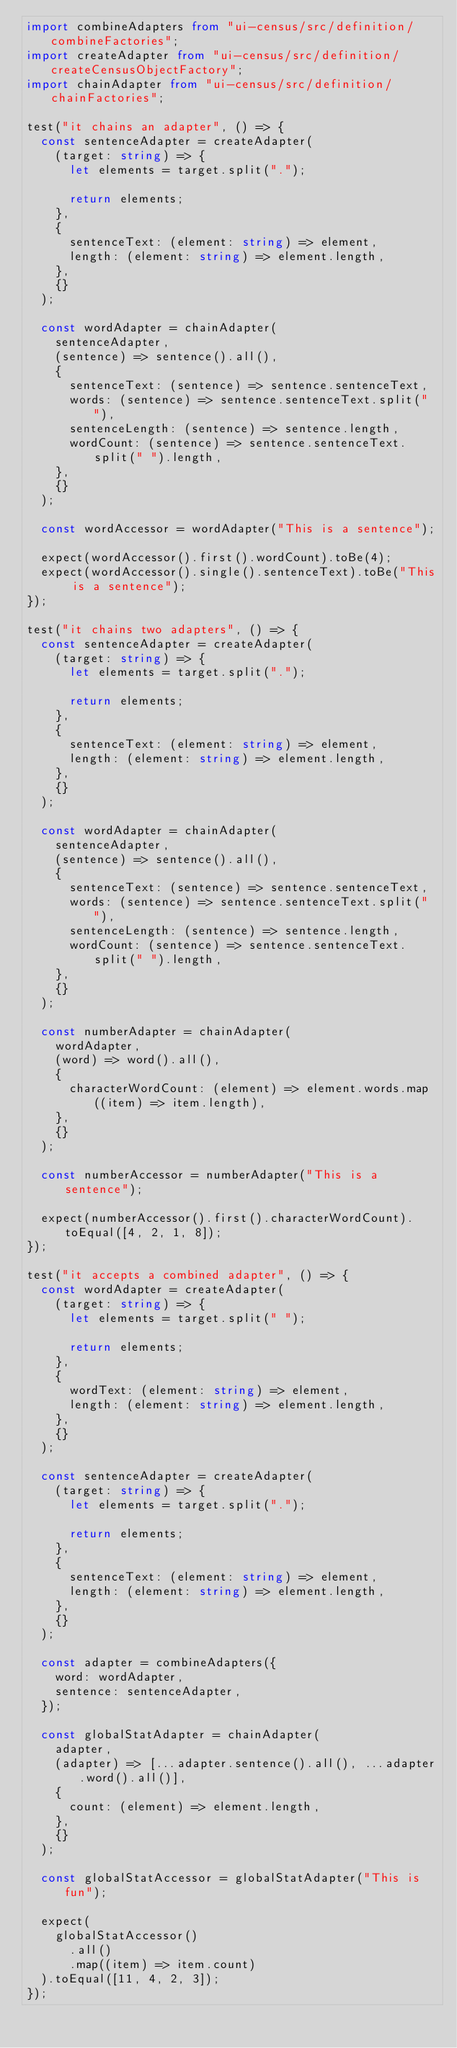Convert code to text. <code><loc_0><loc_0><loc_500><loc_500><_TypeScript_>import combineAdapters from "ui-census/src/definition/combineFactories";
import createAdapter from "ui-census/src/definition/createCensusObjectFactory";
import chainAdapter from "ui-census/src/definition/chainFactories";

test("it chains an adapter", () => {
  const sentenceAdapter = createAdapter(
    (target: string) => {
      let elements = target.split(".");

      return elements;
    },
    {
      sentenceText: (element: string) => element,
      length: (element: string) => element.length,
    },
    {}
  );

  const wordAdapter = chainAdapter(
    sentenceAdapter,
    (sentence) => sentence().all(),
    {
      sentenceText: (sentence) => sentence.sentenceText,
      words: (sentence) => sentence.sentenceText.split(" "),
      sentenceLength: (sentence) => sentence.length,
      wordCount: (sentence) => sentence.sentenceText.split(" ").length,
    },
    {}
  );

  const wordAccessor = wordAdapter("This is a sentence");

  expect(wordAccessor().first().wordCount).toBe(4);
  expect(wordAccessor().single().sentenceText).toBe("This is a sentence");
});

test("it chains two adapters", () => {
  const sentenceAdapter = createAdapter(
    (target: string) => {
      let elements = target.split(".");

      return elements;
    },
    {
      sentenceText: (element: string) => element,
      length: (element: string) => element.length,
    },
    {}
  );

  const wordAdapter = chainAdapter(
    sentenceAdapter,
    (sentence) => sentence().all(),
    {
      sentenceText: (sentence) => sentence.sentenceText,
      words: (sentence) => sentence.sentenceText.split(" "),
      sentenceLength: (sentence) => sentence.length,
      wordCount: (sentence) => sentence.sentenceText.split(" ").length,
    },
    {}
  );

  const numberAdapter = chainAdapter(
    wordAdapter,
    (word) => word().all(),
    {
      characterWordCount: (element) => element.words.map((item) => item.length),
    },
    {}
  );

  const numberAccessor = numberAdapter("This is a sentence");

  expect(numberAccessor().first().characterWordCount).toEqual([4, 2, 1, 8]);
});

test("it accepts a combined adapter", () => {
  const wordAdapter = createAdapter(
    (target: string) => {
      let elements = target.split(" ");

      return elements;
    },
    {
      wordText: (element: string) => element,
      length: (element: string) => element.length,
    },
    {}
  );

  const sentenceAdapter = createAdapter(
    (target: string) => {
      let elements = target.split(".");

      return elements;
    },
    {
      sentenceText: (element: string) => element,
      length: (element: string) => element.length,
    },
    {}
  );

  const adapter = combineAdapters({
    word: wordAdapter,
    sentence: sentenceAdapter,
  });

  const globalStatAdapter = chainAdapter(
    adapter,
    (adapter) => [...adapter.sentence().all(), ...adapter.word().all()],
    {
      count: (element) => element.length,
    },
    {}
  );

  const globalStatAccessor = globalStatAdapter("This is fun");

  expect(
    globalStatAccessor()
      .all()
      .map((item) => item.count)
  ).toEqual([11, 4, 2, 3]);
});
</code> 